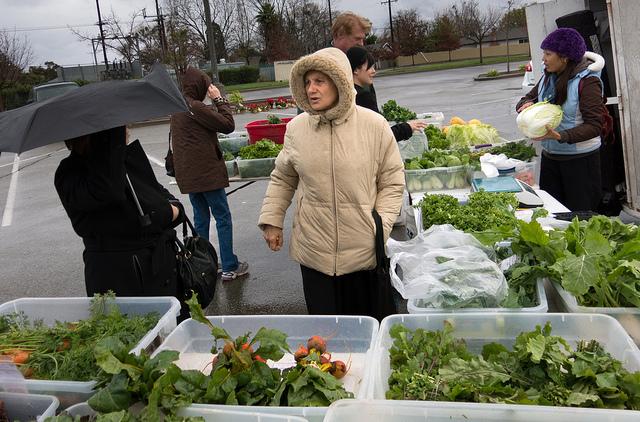Would someone who hates vegetables be excited about this selection?
Keep it brief. No. Is there a truck in this picture?
Give a very brief answer. No. What color is the umbrella?
Give a very brief answer. Black. What is being sold?
Short answer required. Vegetables. What is the woman doing?
Give a very brief answer. Shopping. 